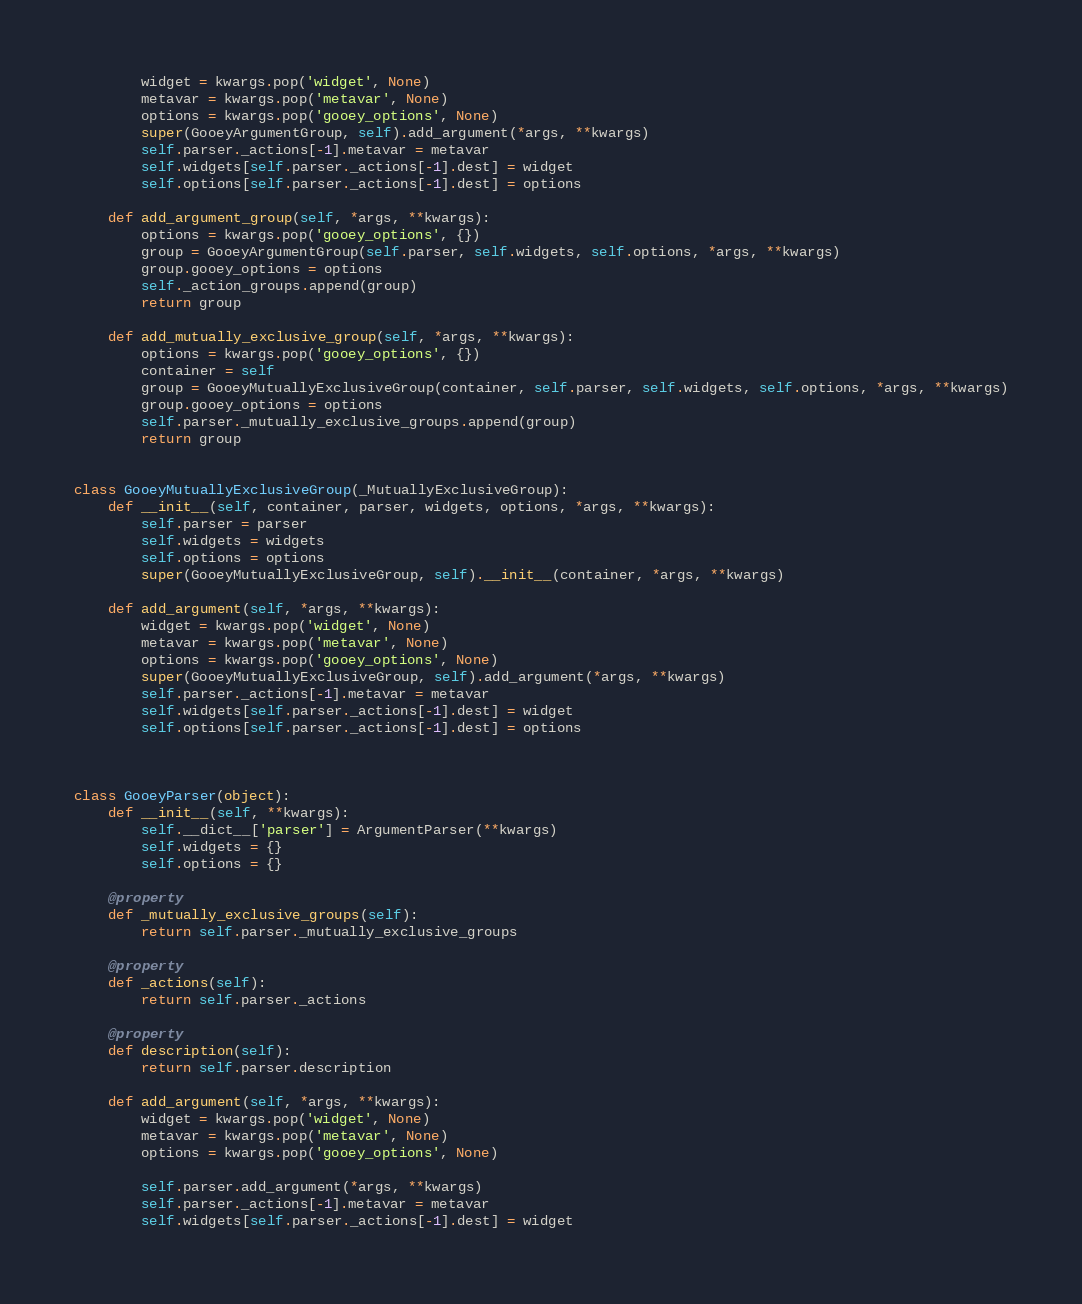Convert code to text. <code><loc_0><loc_0><loc_500><loc_500><_Python_>        widget = kwargs.pop('widget', None)
        metavar = kwargs.pop('metavar', None)
        options = kwargs.pop('gooey_options', None)
        super(GooeyArgumentGroup, self).add_argument(*args, **kwargs)
        self.parser._actions[-1].metavar = metavar
        self.widgets[self.parser._actions[-1].dest] = widget
        self.options[self.parser._actions[-1].dest] = options

    def add_argument_group(self, *args, **kwargs):
        options = kwargs.pop('gooey_options', {})
        group = GooeyArgumentGroup(self.parser, self.widgets, self.options, *args, **kwargs)
        group.gooey_options = options
        self._action_groups.append(group)
        return group

    def add_mutually_exclusive_group(self, *args, **kwargs):
        options = kwargs.pop('gooey_options', {})
        container = self
        group = GooeyMutuallyExclusiveGroup(container, self.parser, self.widgets, self.options, *args, **kwargs)
        group.gooey_options = options
        self.parser._mutually_exclusive_groups.append(group)
        return group


class GooeyMutuallyExclusiveGroup(_MutuallyExclusiveGroup):
    def __init__(self, container, parser, widgets, options, *args, **kwargs):
        self.parser = parser
        self.widgets = widgets
        self.options = options
        super(GooeyMutuallyExclusiveGroup, self).__init__(container, *args, **kwargs)

    def add_argument(self, *args, **kwargs):
        widget = kwargs.pop('widget', None)
        metavar = kwargs.pop('metavar', None)
        options = kwargs.pop('gooey_options', None)
        super(GooeyMutuallyExclusiveGroup, self).add_argument(*args, **kwargs)
        self.parser._actions[-1].metavar = metavar
        self.widgets[self.parser._actions[-1].dest] = widget
        self.options[self.parser._actions[-1].dest] = options



class GooeyParser(object):
    def __init__(self, **kwargs):        
        self.__dict__['parser'] = ArgumentParser(**kwargs)
        self.widgets = {}
        self.options = {}

    @property
    def _mutually_exclusive_groups(self):
        return self.parser._mutually_exclusive_groups

    @property
    def _actions(self):
        return self.parser._actions

    @property
    def description(self):
        return self.parser.description

    def add_argument(self, *args, **kwargs):
        widget = kwargs.pop('widget', None)
        metavar = kwargs.pop('metavar', None)
        options = kwargs.pop('gooey_options', None)

        self.parser.add_argument(*args, **kwargs)
        self.parser._actions[-1].metavar = metavar
        self.widgets[self.parser._actions[-1].dest] = widget</code> 